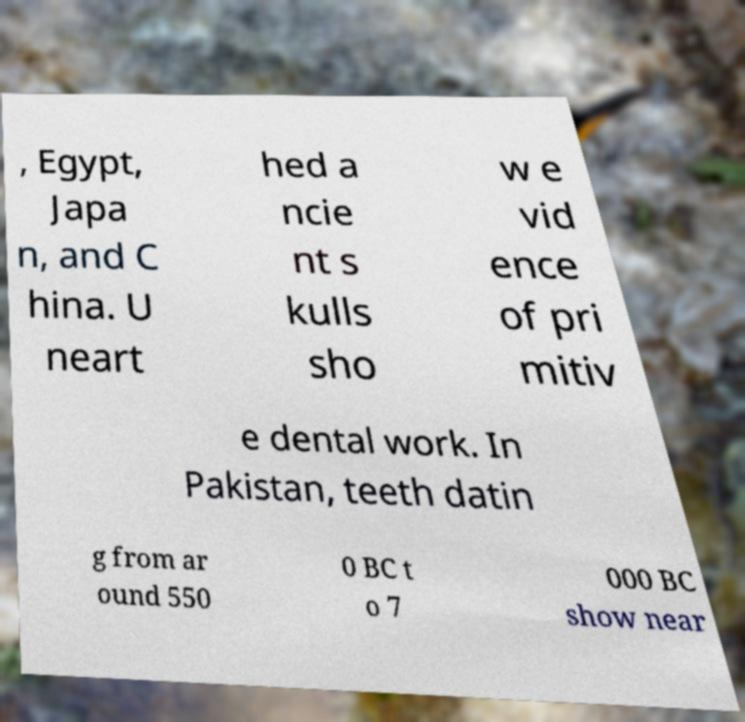There's text embedded in this image that I need extracted. Can you transcribe it verbatim? , Egypt, Japa n, and C hina. U neart hed a ncie nt s kulls sho w e vid ence of pri mitiv e dental work. In Pakistan, teeth datin g from ar ound 550 0 BC t o 7 000 BC show near 